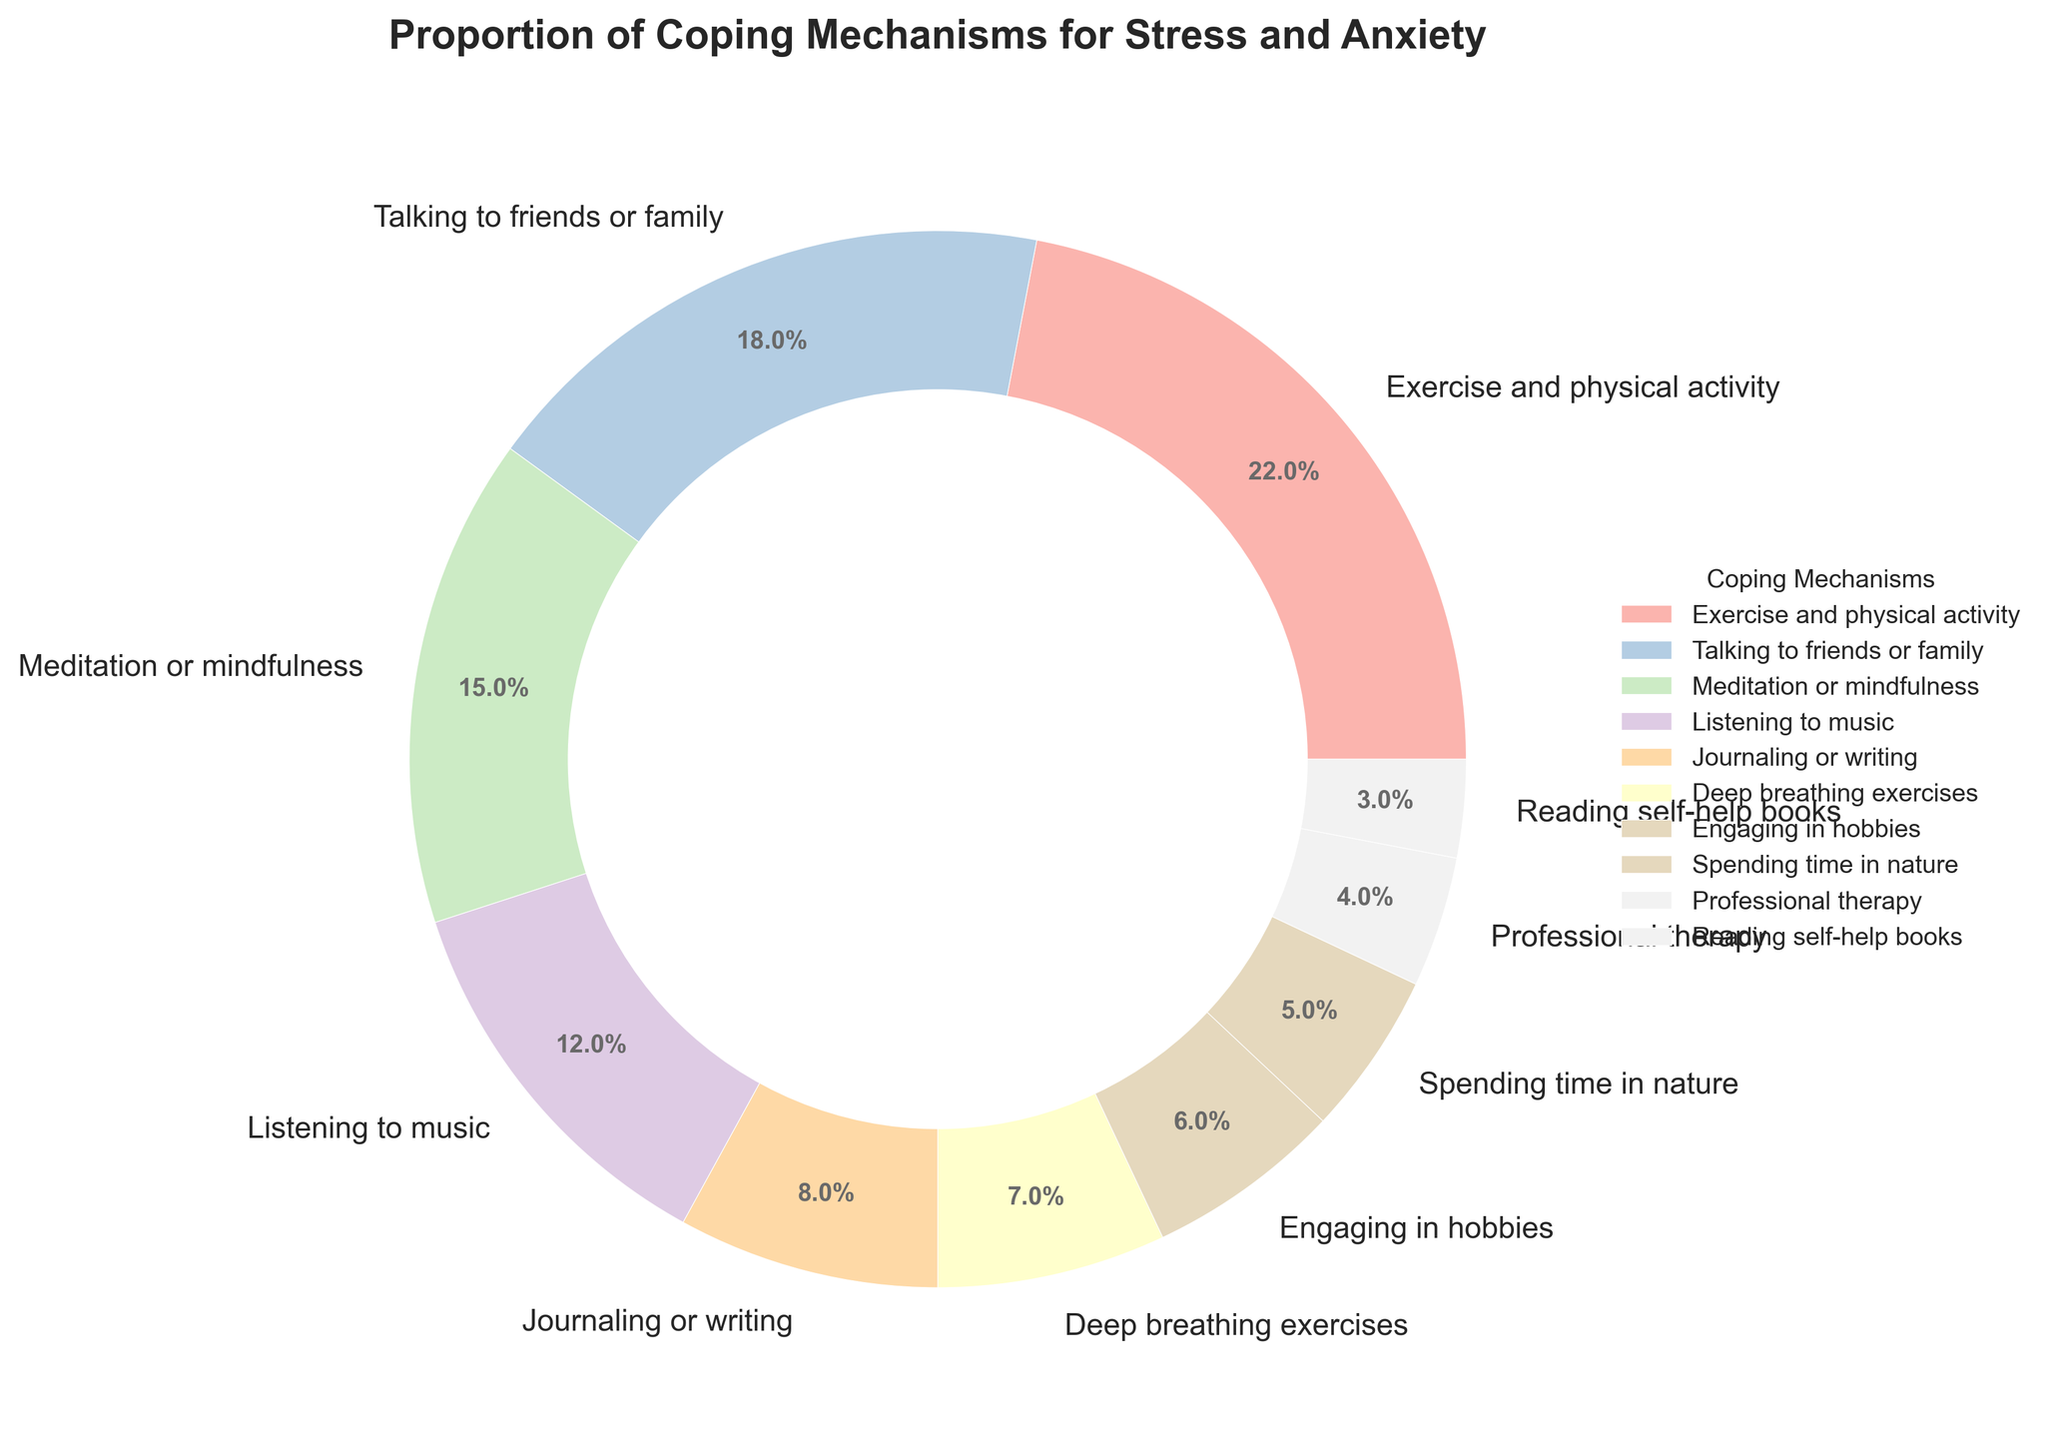What is the coping mechanism with the highest percentage? The coping mechanism with the highest percentage can be identified by looking for the largest segment in the pie chart. This is represented by the wedge that covers the largest area. In this case, it is "Exercise and physical activity" with 22%.
Answer: Exercise and physical activity Which coping mechanism has a higher percentage: Meditation or mindfulness, or Listening to music? To answer this, compare the sizes of the wedges labeled "Meditation or mindfulness" and "Listening to music". "Meditation or mindfulness" has 15%, while "Listening to music" has 12%.
Answer: Meditation or mindfulness What is the combined percentage of Talking to friends or family and Deep breathing exercises? Add the percentages of the segments labeled "Talking to friends or family" and "Deep breathing exercises". That is 18% + 7% = 25%.
Answer: 25% How does the percentage for Engaging in hobbies compare to Spending time in nature? Compare the wedges for "Engaging in hobbies" and "Spending time in nature". "Engaging in hobbies" has 6%, while "Spending time in nature" has 5%.
Answer: Engaging in hobbies Which portion is larger: Professional therapy or Reading self-help books? Compare the wedges labeled "Professional therapy" and "Reading self-help books". "Professional therapy" has a larger segment at 4%, compared to "Reading self-help books" at 3%.
Answer: Professional therapy What is the total percentage of the three coping mechanisms with the smallest proportions? Identify the three smallest segments: "Professional therapy" (4%), "Reading self-help books" (3%), and "Spending time in nature" (5%). Sum these percentages: 4% + 3% + 5% = 12%.
Answer: 12% If the total percentage for Exercise and physical activity doubles, what would it be? The current percentage for "Exercise and physical activity" is 22%. If it doubles, multiply 22% by 2 to get 44%.
Answer: 44% Which coping mechanism falls in the middle in terms of its percentage, and what is its value? To find the middle percentage, the coping mechanisms can be ordered by their percentages. The middle value in this list is the 5th value when sorted. The sorted list: 22%, 18%, 15%, 12%, 8%, 7%, 6%, 5%, 4%, 3%. "Journaling or writing" with 8% is the middle value.
Answer: Journaling or writing, 8% How much larger is the percentage of Exercise and physical activity compared to Professional therapy? Subtract the percentage of "Professional therapy" (4%) from "Exercise and physical activity" (22%): 22% - 4% = 18%.
Answer: 18% 